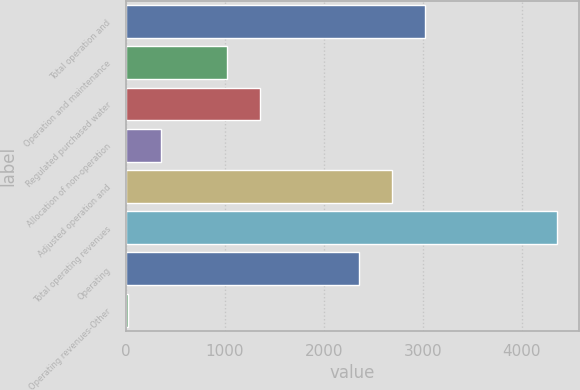Convert chart to OTSL. <chart><loc_0><loc_0><loc_500><loc_500><bar_chart><fcel>Total operation and<fcel>Operation and maintenance<fcel>Regulated purchased water<fcel>Allocation of non-operation<fcel>Adjusted operation and<fcel>Total operating revenues<fcel>Operating<fcel>Operating revenues-Other<nl><fcel>3023.6<fcel>1023.2<fcel>1356.6<fcel>356.4<fcel>2690.2<fcel>4357.2<fcel>2356.8<fcel>23<nl></chart> 